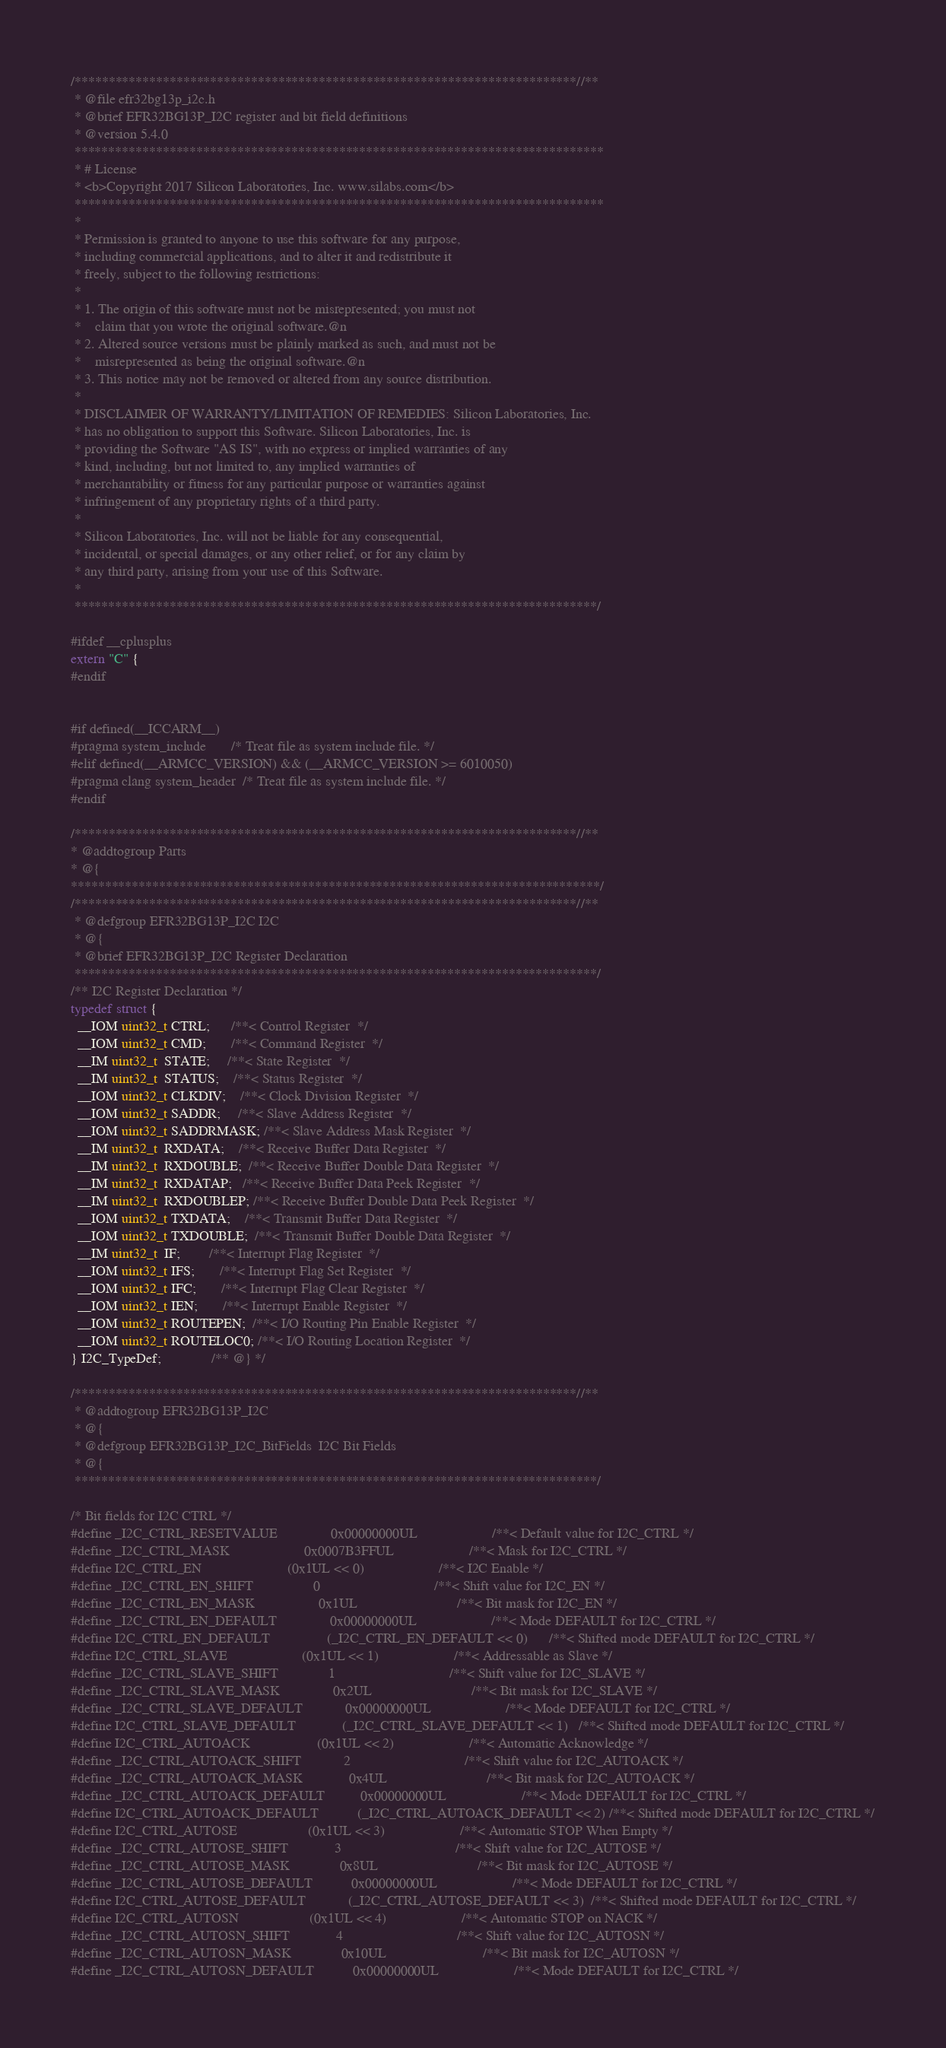Convert code to text. <code><loc_0><loc_0><loc_500><loc_500><_C_>/**************************************************************************//**
 * @file efr32bg13p_i2c.h
 * @brief EFR32BG13P_I2C register and bit field definitions
 * @version 5.4.0
 ******************************************************************************
 * # License
 * <b>Copyright 2017 Silicon Laboratories, Inc. www.silabs.com</b>
 ******************************************************************************
 *
 * Permission is granted to anyone to use this software for any purpose,
 * including commercial applications, and to alter it and redistribute it
 * freely, subject to the following restrictions:
 *
 * 1. The origin of this software must not be misrepresented; you must not
 *    claim that you wrote the original software.@n
 * 2. Altered source versions must be plainly marked as such, and must not be
 *    misrepresented as being the original software.@n
 * 3. This notice may not be removed or altered from any source distribution.
 *
 * DISCLAIMER OF WARRANTY/LIMITATION OF REMEDIES: Silicon Laboratories, Inc.
 * has no obligation to support this Software. Silicon Laboratories, Inc. is
 * providing the Software "AS IS", with no express or implied warranties of any
 * kind, including, but not limited to, any implied warranties of
 * merchantability or fitness for any particular purpose or warranties against
 * infringement of any proprietary rights of a third party.
 *
 * Silicon Laboratories, Inc. will not be liable for any consequential,
 * incidental, or special damages, or any other relief, or for any claim by
 * any third party, arising from your use of this Software.
 *
 *****************************************************************************/

#ifdef __cplusplus
extern "C" {
#endif


#if defined(__ICCARM__)
#pragma system_include       /* Treat file as system include file. */
#elif defined(__ARMCC_VERSION) && (__ARMCC_VERSION >= 6010050)
#pragma clang system_header  /* Treat file as system include file. */
#endif

/**************************************************************************//**
* @addtogroup Parts
* @{
******************************************************************************/
/**************************************************************************//**
 * @defgroup EFR32BG13P_I2C I2C
 * @{
 * @brief EFR32BG13P_I2C Register Declaration
 *****************************************************************************/
/** I2C Register Declaration */
typedef struct {
  __IOM uint32_t CTRL;      /**< Control Register  */
  __IOM uint32_t CMD;       /**< Command Register  */
  __IM uint32_t  STATE;     /**< State Register  */
  __IM uint32_t  STATUS;    /**< Status Register  */
  __IOM uint32_t CLKDIV;    /**< Clock Division Register  */
  __IOM uint32_t SADDR;     /**< Slave Address Register  */
  __IOM uint32_t SADDRMASK; /**< Slave Address Mask Register  */
  __IM uint32_t  RXDATA;    /**< Receive Buffer Data Register  */
  __IM uint32_t  RXDOUBLE;  /**< Receive Buffer Double Data Register  */
  __IM uint32_t  RXDATAP;   /**< Receive Buffer Data Peek Register  */
  __IM uint32_t  RXDOUBLEP; /**< Receive Buffer Double Data Peek Register  */
  __IOM uint32_t TXDATA;    /**< Transmit Buffer Data Register  */
  __IOM uint32_t TXDOUBLE;  /**< Transmit Buffer Double Data Register  */
  __IM uint32_t  IF;        /**< Interrupt Flag Register  */
  __IOM uint32_t IFS;       /**< Interrupt Flag Set Register  */
  __IOM uint32_t IFC;       /**< Interrupt Flag Clear Register  */
  __IOM uint32_t IEN;       /**< Interrupt Enable Register  */
  __IOM uint32_t ROUTEPEN;  /**< I/O Routing Pin Enable Register  */
  __IOM uint32_t ROUTELOC0; /**< I/O Routing Location Register  */
} I2C_TypeDef;              /** @} */

/**************************************************************************//**
 * @addtogroup EFR32BG13P_I2C
 * @{
 * @defgroup EFR32BG13P_I2C_BitFields  I2C Bit Fields
 * @{
 *****************************************************************************/

/* Bit fields for I2C CTRL */
#define _I2C_CTRL_RESETVALUE               0x00000000UL                     /**< Default value for I2C_CTRL */
#define _I2C_CTRL_MASK                     0x0007B3FFUL                     /**< Mask for I2C_CTRL */
#define I2C_CTRL_EN                        (0x1UL << 0)                     /**< I2C Enable */
#define _I2C_CTRL_EN_SHIFT                 0                                /**< Shift value for I2C_EN */
#define _I2C_CTRL_EN_MASK                  0x1UL                            /**< Bit mask for I2C_EN */
#define _I2C_CTRL_EN_DEFAULT               0x00000000UL                     /**< Mode DEFAULT for I2C_CTRL */
#define I2C_CTRL_EN_DEFAULT                (_I2C_CTRL_EN_DEFAULT << 0)      /**< Shifted mode DEFAULT for I2C_CTRL */
#define I2C_CTRL_SLAVE                     (0x1UL << 1)                     /**< Addressable as Slave */
#define _I2C_CTRL_SLAVE_SHIFT              1                                /**< Shift value for I2C_SLAVE */
#define _I2C_CTRL_SLAVE_MASK               0x2UL                            /**< Bit mask for I2C_SLAVE */
#define _I2C_CTRL_SLAVE_DEFAULT            0x00000000UL                     /**< Mode DEFAULT for I2C_CTRL */
#define I2C_CTRL_SLAVE_DEFAULT             (_I2C_CTRL_SLAVE_DEFAULT << 1)   /**< Shifted mode DEFAULT for I2C_CTRL */
#define I2C_CTRL_AUTOACK                   (0x1UL << 2)                     /**< Automatic Acknowledge */
#define _I2C_CTRL_AUTOACK_SHIFT            2                                /**< Shift value for I2C_AUTOACK */
#define _I2C_CTRL_AUTOACK_MASK             0x4UL                            /**< Bit mask for I2C_AUTOACK */
#define _I2C_CTRL_AUTOACK_DEFAULT          0x00000000UL                     /**< Mode DEFAULT for I2C_CTRL */
#define I2C_CTRL_AUTOACK_DEFAULT           (_I2C_CTRL_AUTOACK_DEFAULT << 2) /**< Shifted mode DEFAULT for I2C_CTRL */
#define I2C_CTRL_AUTOSE                    (0x1UL << 3)                     /**< Automatic STOP When Empty */
#define _I2C_CTRL_AUTOSE_SHIFT             3                                /**< Shift value for I2C_AUTOSE */
#define _I2C_CTRL_AUTOSE_MASK              0x8UL                            /**< Bit mask for I2C_AUTOSE */
#define _I2C_CTRL_AUTOSE_DEFAULT           0x00000000UL                     /**< Mode DEFAULT for I2C_CTRL */
#define I2C_CTRL_AUTOSE_DEFAULT            (_I2C_CTRL_AUTOSE_DEFAULT << 3)  /**< Shifted mode DEFAULT for I2C_CTRL */
#define I2C_CTRL_AUTOSN                    (0x1UL << 4)                     /**< Automatic STOP on NACK */
#define _I2C_CTRL_AUTOSN_SHIFT             4                                /**< Shift value for I2C_AUTOSN */
#define _I2C_CTRL_AUTOSN_MASK              0x10UL                           /**< Bit mask for I2C_AUTOSN */
#define _I2C_CTRL_AUTOSN_DEFAULT           0x00000000UL                     /**< Mode DEFAULT for I2C_CTRL */</code> 